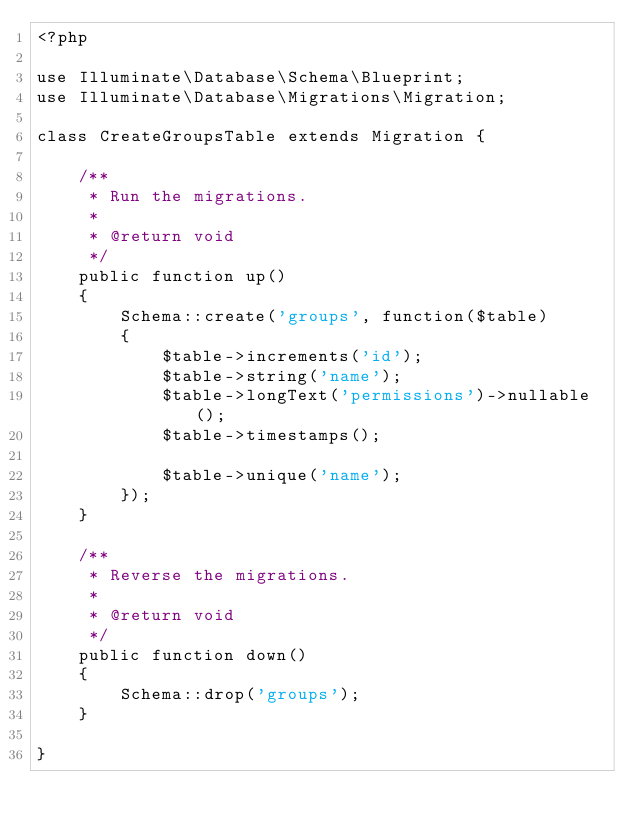Convert code to text. <code><loc_0><loc_0><loc_500><loc_500><_PHP_><?php

use Illuminate\Database\Schema\Blueprint;
use Illuminate\Database\Migrations\Migration;

class CreateGroupsTable extends Migration {

	/**
	 * Run the migrations.
	 *
	 * @return void
	 */
	public function up()
	{
		Schema::create('groups', function($table)
		{
			$table->increments('id');
			$table->string('name');
			$table->longText('permissions')->nullable();
			$table->timestamps();

			$table->unique('name');
		});
	}

	/**
	 * Reverse the migrations.
	 *
	 * @return void
	 */
	public function down()
	{
		Schema::drop('groups');
	}

}
</code> 